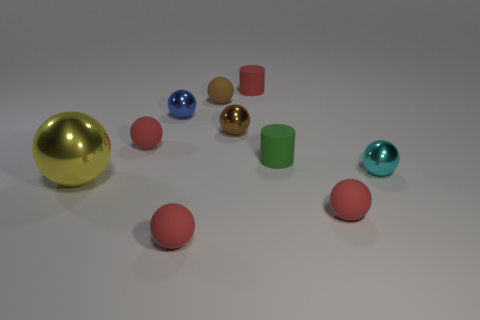How many red spheres must be subtracted to get 1 red spheres? 2 Subtract all gray cubes. How many red spheres are left? 3 Subtract all red spheres. How many spheres are left? 5 Subtract 4 balls. How many balls are left? 4 Subtract all big balls. How many balls are left? 7 Subtract all red balls. Subtract all red cubes. How many balls are left? 5 Subtract all balls. How many objects are left? 2 Subtract 0 cyan blocks. How many objects are left? 10 Subtract all yellow metallic things. Subtract all tiny cyan balls. How many objects are left? 8 Add 9 tiny red rubber cylinders. How many tiny red rubber cylinders are left? 10 